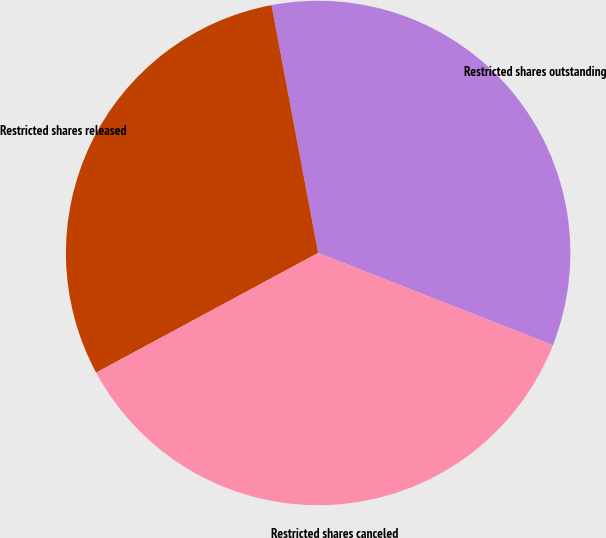Convert chart. <chart><loc_0><loc_0><loc_500><loc_500><pie_chart><fcel>Restricted shares outstanding<fcel>Restricted shares released<fcel>Restricted shares canceled<nl><fcel>33.92%<fcel>29.91%<fcel>36.17%<nl></chart> 